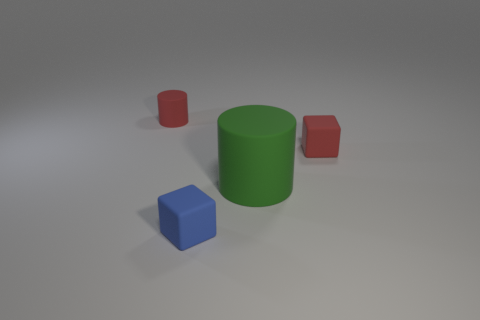Add 1 tiny red matte objects. How many objects exist? 5 Subtract all red cylinders. Subtract all yellow blocks. How many cylinders are left? 1 Add 1 large matte cylinders. How many large matte cylinders exist? 2 Subtract 0 yellow cubes. How many objects are left? 4 Subtract all red rubber things. Subtract all tiny blue rubber things. How many objects are left? 1 Add 1 blocks. How many blocks are left? 3 